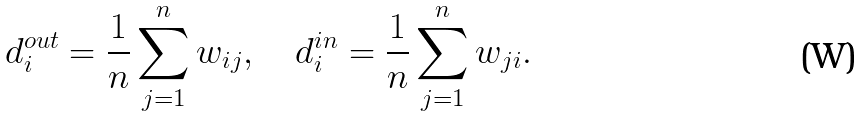<formula> <loc_0><loc_0><loc_500><loc_500>d ^ { o u t } _ { i } = \frac { 1 } { n } \sum _ { j = 1 } ^ { n } w _ { i j } , \quad d ^ { i n } _ { i } = \frac { 1 } { n } \sum _ { j = 1 } ^ { n } w _ { j i } .</formula> 